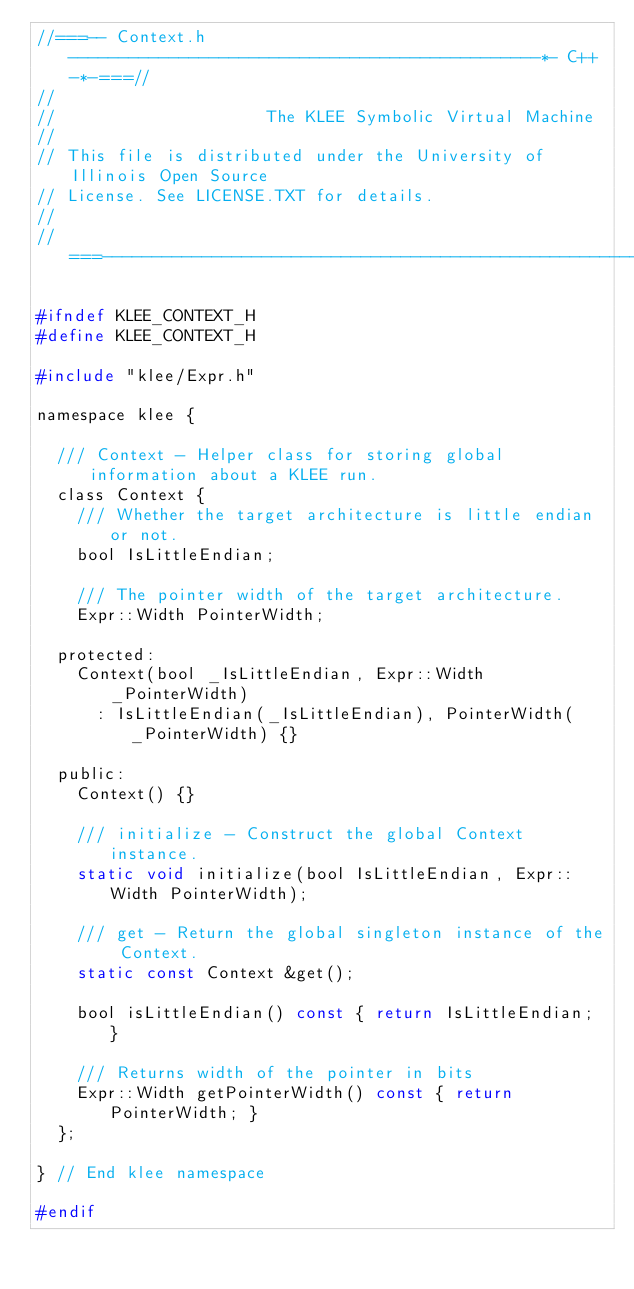<code> <loc_0><loc_0><loc_500><loc_500><_C_>//===-- Context.h -----------------------------------------------*- C++ -*-===//
//
//                     The KLEE Symbolic Virtual Machine
//
// This file is distributed under the University of Illinois Open Source
// License. See LICENSE.TXT for details.
//
//===----------------------------------------------------------------------===//

#ifndef KLEE_CONTEXT_H
#define KLEE_CONTEXT_H

#include "klee/Expr.h"

namespace klee {

  /// Context - Helper class for storing global information about a KLEE run.
  class Context {
    /// Whether the target architecture is little endian or not.
    bool IsLittleEndian;

    /// The pointer width of the target architecture.
    Expr::Width PointerWidth;

  protected:
    Context(bool _IsLittleEndian, Expr::Width _PointerWidth)
      : IsLittleEndian(_IsLittleEndian), PointerWidth(_PointerWidth) {}
    
  public:
    Context() {}

    /// initialize - Construct the global Context instance.
    static void initialize(bool IsLittleEndian, Expr::Width PointerWidth);

    /// get - Return the global singleton instance of the Context.
    static const Context &get();

    bool isLittleEndian() const { return IsLittleEndian; }

    /// Returns width of the pointer in bits
    Expr::Width getPointerWidth() const { return PointerWidth; }
  };
  
} // End klee namespace

#endif
</code> 